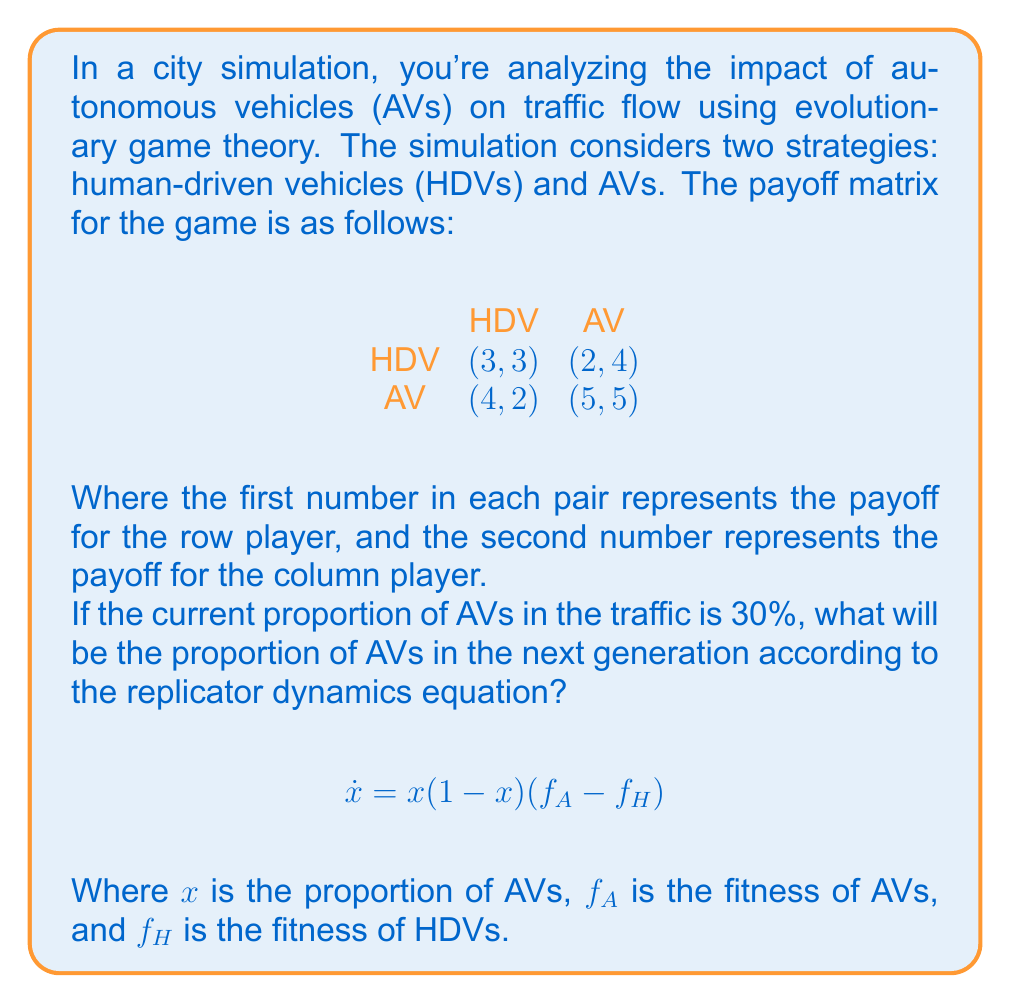What is the answer to this math problem? To solve this problem, we need to follow these steps:

1. Calculate the fitness of AVs ($f_A$) and HDVs ($f_H$) based on the current proportion of AVs.
2. Apply the replicator dynamics equation to find the rate of change of the AV proportion.
3. Use this rate to estimate the proportion of AVs in the next generation.

Step 1: Calculate fitness

Let $x = 0.3$ be the current proportion of AVs.

For AVs:
$f_A = 4(1-x) + 5x = 4(0.7) + 5(0.3) = 2.8 + 1.5 = 4.3$

For HDVs:
$f_H = 3(1-x) + 2x = 3(0.7) + 2(0.3) = 2.1 + 0.6 = 2.7$

Step 2: Apply the replicator dynamics equation

$$\begin{align}
\dot{x} &= x(1-x)(f_A - f_H) \\
&= 0.3(1-0.3)(4.3 - 2.7) \\
&= 0.3(0.7)(1.6) \\
&= 0.336
\end{align}$$

Step 3: Estimate the proportion of AVs in the next generation

Assuming a small time step (e.g., $\Delta t = 1$), we can approximate the new proportion as:

$$x_{new} = x + \dot{x} \cdot \Delta t = 0.3 + 0.336 \cdot 1 = 0.636$$

Therefore, the proportion of AVs in the next generation will be approximately 63.6%.
Answer: The proportion of autonomous vehicles in the next generation will be approximately 63.6%. 